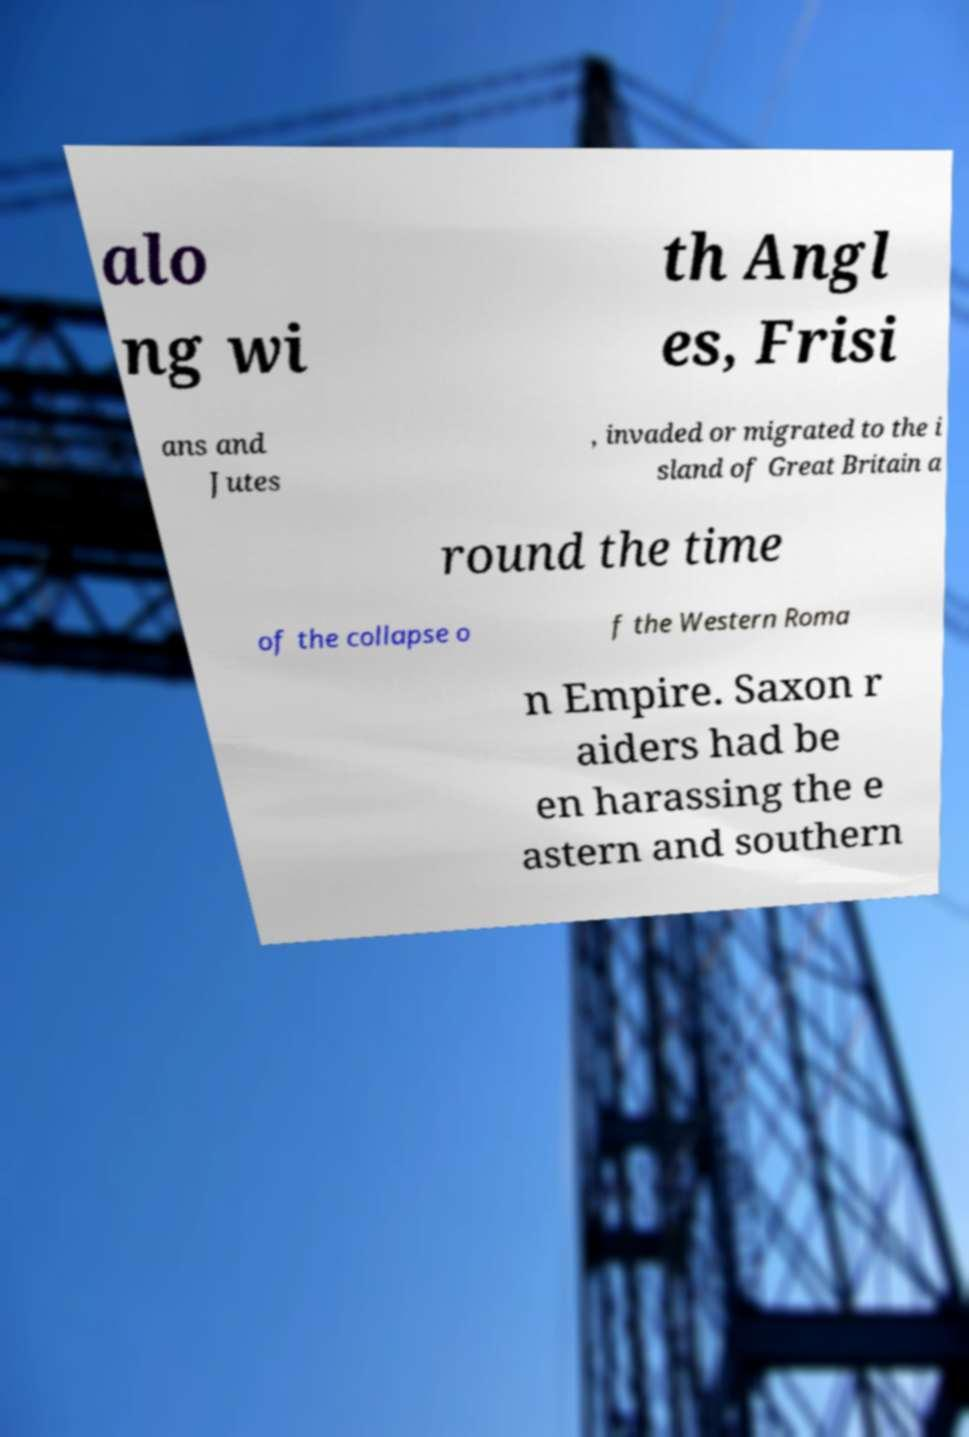For documentation purposes, I need the text within this image transcribed. Could you provide that? alo ng wi th Angl es, Frisi ans and Jutes , invaded or migrated to the i sland of Great Britain a round the time of the collapse o f the Western Roma n Empire. Saxon r aiders had be en harassing the e astern and southern 